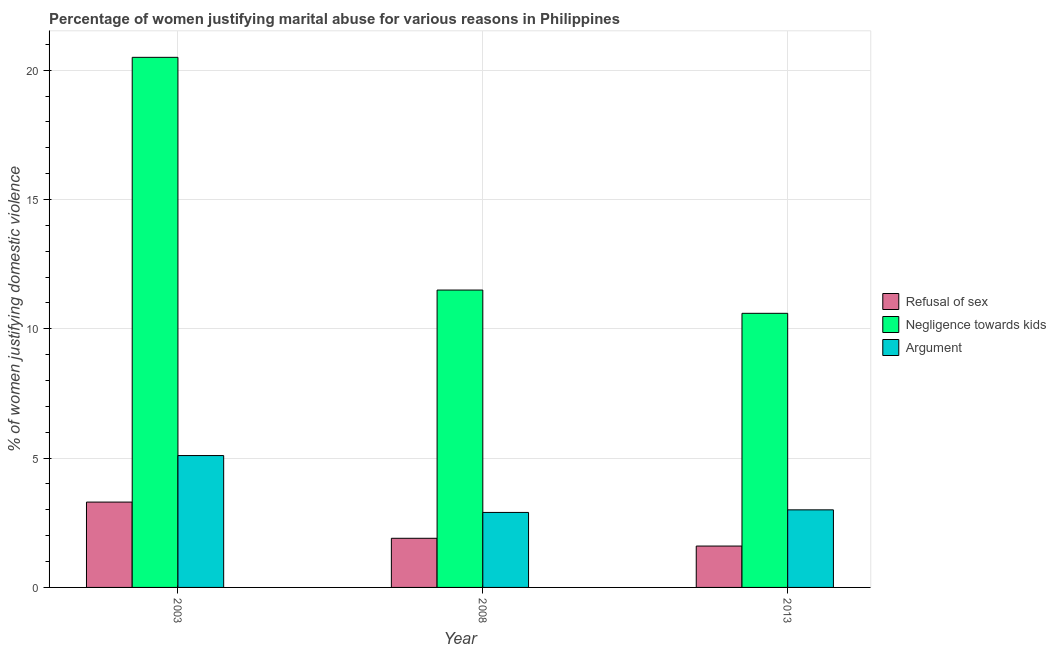How many groups of bars are there?
Provide a succinct answer. 3. Are the number of bars per tick equal to the number of legend labels?
Your answer should be very brief. Yes. Are the number of bars on each tick of the X-axis equal?
Provide a short and direct response. Yes. How many bars are there on the 3rd tick from the right?
Your answer should be very brief. 3. What is the label of the 3rd group of bars from the left?
Offer a terse response. 2013. In how many cases, is the number of bars for a given year not equal to the number of legend labels?
Make the answer very short. 0. What is the percentage of women justifying domestic violence due to refusal of sex in 2003?
Offer a very short reply. 3.3. Across all years, what is the maximum percentage of women justifying domestic violence due to refusal of sex?
Keep it short and to the point. 3.3. In which year was the percentage of women justifying domestic violence due to negligence towards kids maximum?
Ensure brevity in your answer.  2003. What is the total percentage of women justifying domestic violence due to negligence towards kids in the graph?
Keep it short and to the point. 42.6. What is the difference between the percentage of women justifying domestic violence due to negligence towards kids in 2008 and that in 2013?
Offer a very short reply. 0.9. What is the average percentage of women justifying domestic violence due to negligence towards kids per year?
Your response must be concise. 14.2. What is the ratio of the percentage of women justifying domestic violence due to arguments in 2003 to that in 2013?
Keep it short and to the point. 1.7. What is the difference between the highest and the second highest percentage of women justifying domestic violence due to arguments?
Offer a very short reply. 2.1. What is the difference between the highest and the lowest percentage of women justifying domestic violence due to negligence towards kids?
Give a very brief answer. 9.9. Is the sum of the percentage of women justifying domestic violence due to arguments in 2003 and 2008 greater than the maximum percentage of women justifying domestic violence due to negligence towards kids across all years?
Your answer should be compact. Yes. What does the 1st bar from the left in 2013 represents?
Give a very brief answer. Refusal of sex. What does the 1st bar from the right in 2013 represents?
Your response must be concise. Argument. How many bars are there?
Keep it short and to the point. 9. How many years are there in the graph?
Offer a very short reply. 3. Are the values on the major ticks of Y-axis written in scientific E-notation?
Your answer should be compact. No. Does the graph contain grids?
Provide a succinct answer. Yes. How are the legend labels stacked?
Your answer should be very brief. Vertical. What is the title of the graph?
Ensure brevity in your answer.  Percentage of women justifying marital abuse for various reasons in Philippines. Does "Agriculture" appear as one of the legend labels in the graph?
Your answer should be compact. No. What is the label or title of the Y-axis?
Offer a terse response. % of women justifying domestic violence. Across all years, what is the maximum % of women justifying domestic violence of Refusal of sex?
Offer a very short reply. 3.3. Across all years, what is the maximum % of women justifying domestic violence in Negligence towards kids?
Your answer should be very brief. 20.5. Across all years, what is the maximum % of women justifying domestic violence of Argument?
Keep it short and to the point. 5.1. Across all years, what is the minimum % of women justifying domestic violence in Refusal of sex?
Make the answer very short. 1.6. Across all years, what is the minimum % of women justifying domestic violence in Argument?
Your answer should be very brief. 2.9. What is the total % of women justifying domestic violence in Negligence towards kids in the graph?
Ensure brevity in your answer.  42.6. What is the difference between the % of women justifying domestic violence in Refusal of sex in 2003 and that in 2008?
Offer a very short reply. 1.4. What is the difference between the % of women justifying domestic violence of Negligence towards kids in 2003 and that in 2008?
Give a very brief answer. 9. What is the difference between the % of women justifying domestic violence in Refusal of sex in 2003 and that in 2013?
Provide a succinct answer. 1.7. What is the difference between the % of women justifying domestic violence of Negligence towards kids in 2003 and that in 2013?
Provide a short and direct response. 9.9. What is the difference between the % of women justifying domestic violence of Argument in 2008 and that in 2013?
Offer a terse response. -0.1. What is the difference between the % of women justifying domestic violence in Refusal of sex in 2003 and the % of women justifying domestic violence in Argument in 2008?
Your answer should be very brief. 0.4. What is the difference between the % of women justifying domestic violence of Refusal of sex in 2003 and the % of women justifying domestic violence of Argument in 2013?
Provide a succinct answer. 0.3. What is the difference between the % of women justifying domestic violence of Negligence towards kids in 2008 and the % of women justifying domestic violence of Argument in 2013?
Keep it short and to the point. 8.5. What is the average % of women justifying domestic violence of Refusal of sex per year?
Offer a terse response. 2.27. What is the average % of women justifying domestic violence of Negligence towards kids per year?
Make the answer very short. 14.2. What is the average % of women justifying domestic violence in Argument per year?
Provide a short and direct response. 3.67. In the year 2003, what is the difference between the % of women justifying domestic violence in Refusal of sex and % of women justifying domestic violence in Negligence towards kids?
Provide a short and direct response. -17.2. In the year 2008, what is the difference between the % of women justifying domestic violence of Negligence towards kids and % of women justifying domestic violence of Argument?
Your answer should be very brief. 8.6. In the year 2013, what is the difference between the % of women justifying domestic violence in Refusal of sex and % of women justifying domestic violence in Negligence towards kids?
Your answer should be very brief. -9. In the year 2013, what is the difference between the % of women justifying domestic violence of Negligence towards kids and % of women justifying domestic violence of Argument?
Keep it short and to the point. 7.6. What is the ratio of the % of women justifying domestic violence of Refusal of sex in 2003 to that in 2008?
Your response must be concise. 1.74. What is the ratio of the % of women justifying domestic violence of Negligence towards kids in 2003 to that in 2008?
Keep it short and to the point. 1.78. What is the ratio of the % of women justifying domestic violence of Argument in 2003 to that in 2008?
Your response must be concise. 1.76. What is the ratio of the % of women justifying domestic violence in Refusal of sex in 2003 to that in 2013?
Provide a short and direct response. 2.06. What is the ratio of the % of women justifying domestic violence of Negligence towards kids in 2003 to that in 2013?
Make the answer very short. 1.93. What is the ratio of the % of women justifying domestic violence in Refusal of sex in 2008 to that in 2013?
Keep it short and to the point. 1.19. What is the ratio of the % of women justifying domestic violence in Negligence towards kids in 2008 to that in 2013?
Your response must be concise. 1.08. What is the ratio of the % of women justifying domestic violence in Argument in 2008 to that in 2013?
Ensure brevity in your answer.  0.97. What is the difference between the highest and the second highest % of women justifying domestic violence of Refusal of sex?
Your response must be concise. 1.4. What is the difference between the highest and the lowest % of women justifying domestic violence in Refusal of sex?
Offer a terse response. 1.7. 